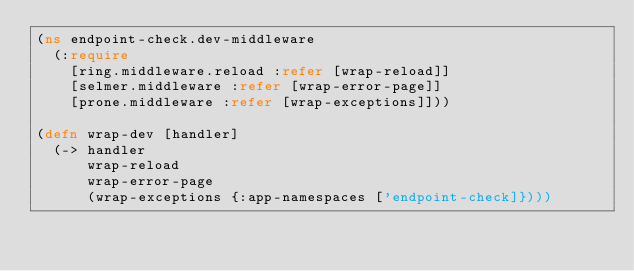Convert code to text. <code><loc_0><loc_0><loc_500><loc_500><_Clojure_>(ns endpoint-check.dev-middleware
  (:require
    [ring.middleware.reload :refer [wrap-reload]]
    [selmer.middleware :refer [wrap-error-page]]
    [prone.middleware :refer [wrap-exceptions]]))

(defn wrap-dev [handler]
  (-> handler
      wrap-reload
      wrap-error-page
      (wrap-exceptions {:app-namespaces ['endpoint-check]})))
</code> 